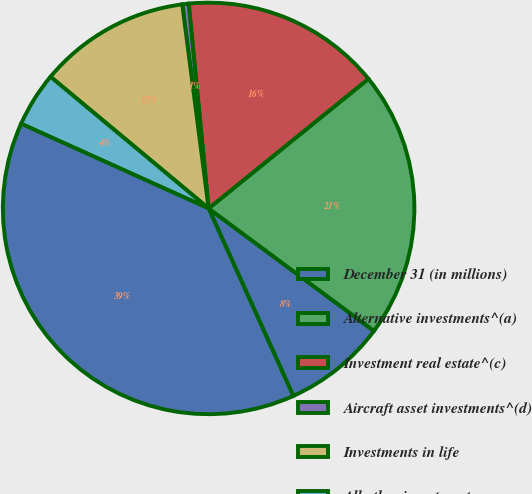Convert chart. <chart><loc_0><loc_0><loc_500><loc_500><pie_chart><fcel>December 31 (in millions)<fcel>Alternative investments^(a)<fcel>Investment real estate^(c)<fcel>Aircraft asset investments^(d)<fcel>Investments in life<fcel>All other investments<fcel>Total<nl><fcel>8.1%<fcel>20.99%<fcel>15.7%<fcel>0.5%<fcel>11.9%<fcel>4.3%<fcel>38.5%<nl></chart> 